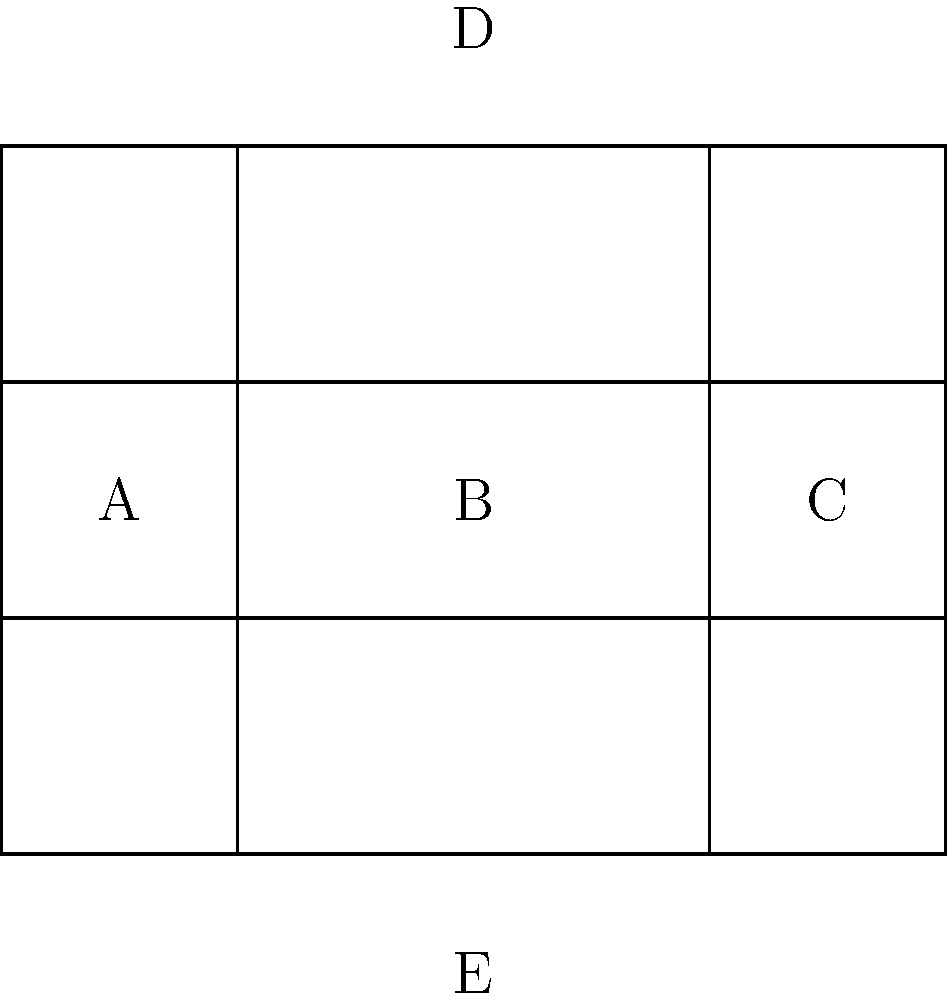The blueprint above represents an unfolded model of the new Lee Heights Community Center. When folded, which two sections will form the roof of the building? To determine which sections will form the roof of the building when the blueprint is folded into a 3D model, let's follow these steps:

1. Analyze the blueprint:
   - The blueprint shows a rectangular shape divided into 5 sections: A, B, C, D, and E.
   - Sections A, B, and C are vertically aligned and of equal size.
   - Sections D and E are horizontally aligned with B, one above and one below.

2. Visualize the folding process:
   - Sections A and C will fold inward along the dotted lines to form the sides of the building.
   - Section B will remain as the front (or back) of the building.
   - This leaves sections D and E to be folded.

3. Determine the roof:
   - In a typical building structure, the roof is on top.
   - When folded, section D will be positioned on top of the structure.
   - Section E will form the base or floor of the building.

4. Conclusion:
   - Section D will definitely form part of the roof.
   - However, a building typically has a pitched roof with two sloping sides.
   - To create this, section C would need to be folded at an angle to meet section D.

Therefore, sections C and D will together form the roof of the building when the blueprint is folded into a 3D model.
Answer: C and D 